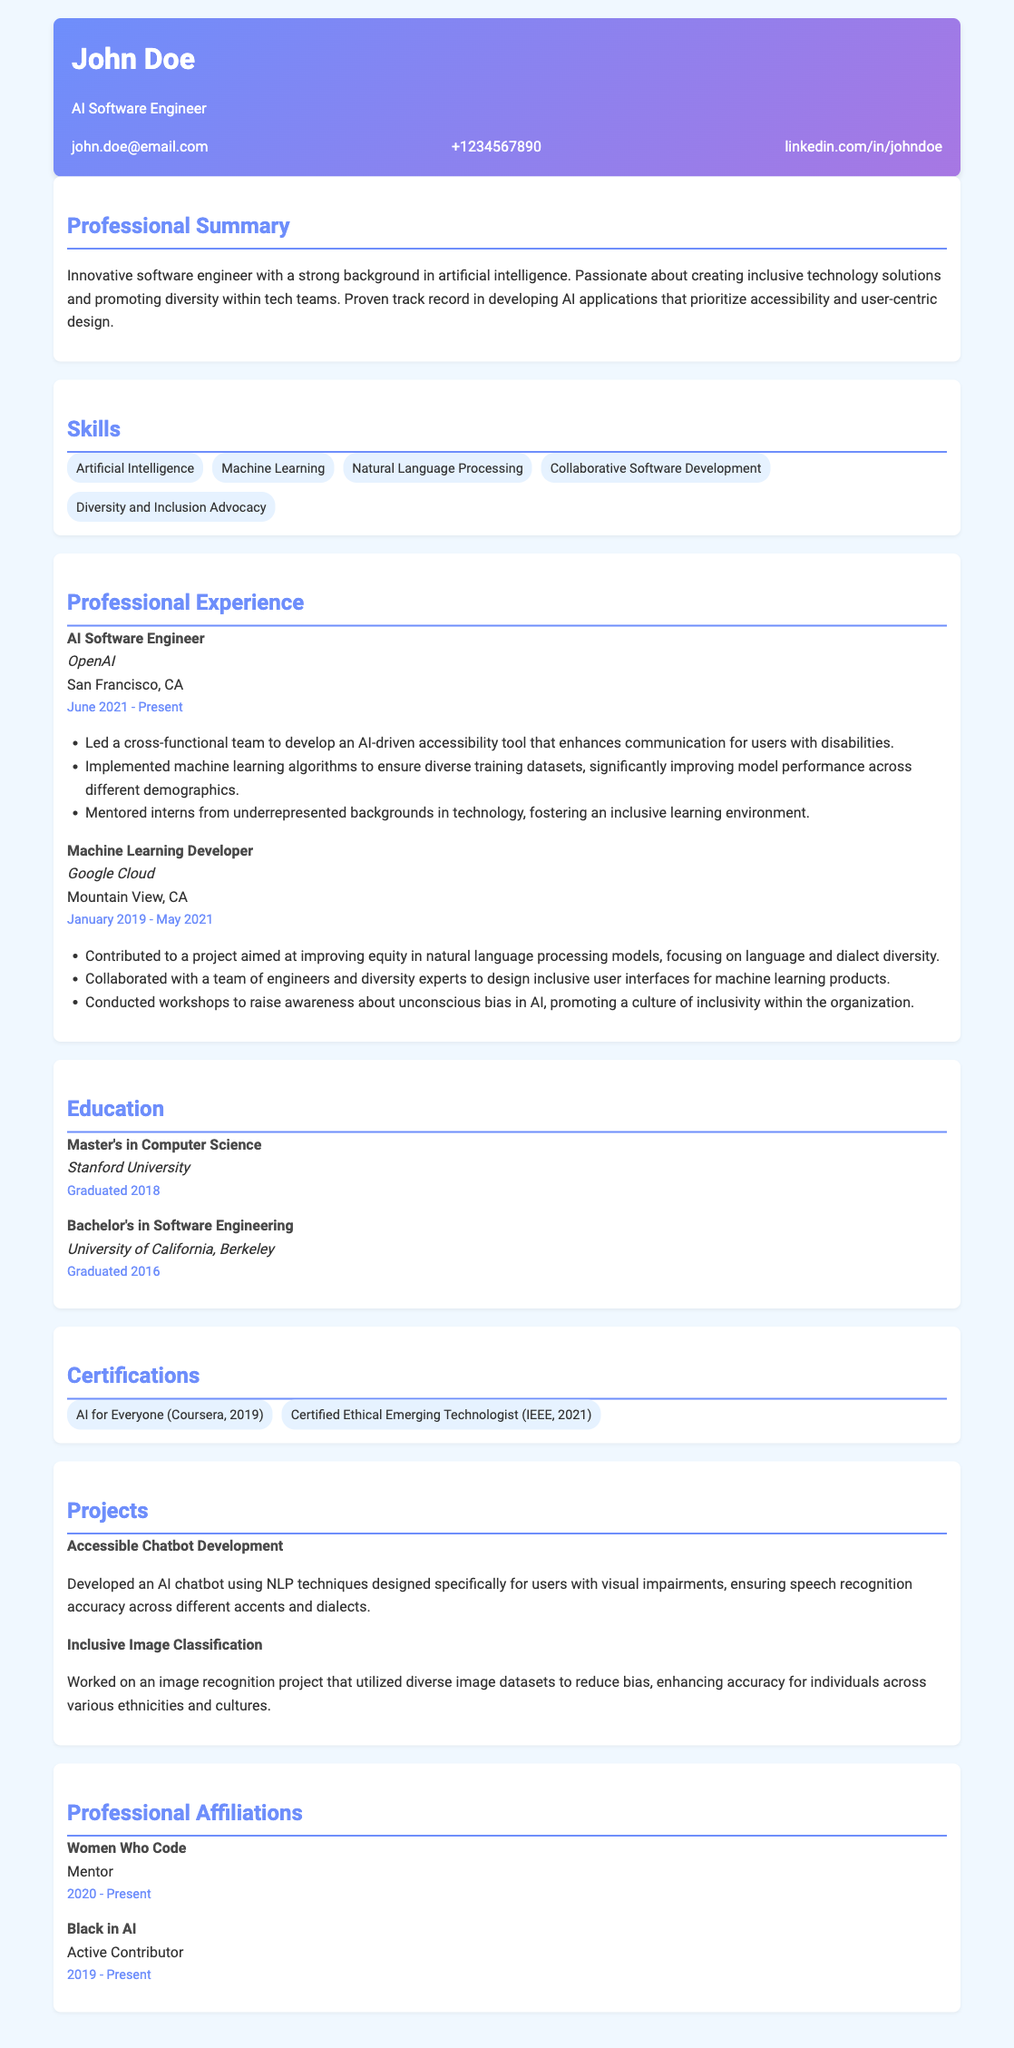What is the name of the candidate? The name of the candidate is prominently displayed at the top of the CV.
Answer: John Doe What is the job title at OpenAI? The job title is listed under the professional experience section for the candidate's role at OpenAI.
Answer: AI Software Engineer When did the candidate graduate from Stanford University? The graduation date for the Master's degree is specified in the education section.
Answer: Graduated 2018 What is one of the projects mentioned that focuses on accessibility? The candidate describes projects in the section dedicated to projects, and one specifically emphasizes accessibility.
Answer: Accessible Chatbot Development Which organization does the candidate mentor for? The candidate mentions their involvement in mentorship in the professional affiliations section.
Answer: Women Who Code What skill indicates the candidate's commitment to diversity? The skills listed include specific references to the candidate's advocacy for diversity.
Answer: Diversity and Inclusion Advocacy Which machine learning topic did the candidate contribute to at Google Cloud? The contribution is described in the professional experience section and relates to natural language processing.
Answer: Language and dialect diversity What kind of workshops did the candidate conduct at Google Cloud? The candidate mentions raising awareness about a particular issue within the organization in the description of their role at Google Cloud.
Answer: Unconscious bias in AI How many years did the candidate work as a Machine Learning Developer? This is determined by the dates listed for the position under professional experience.
Answer: 2 years 